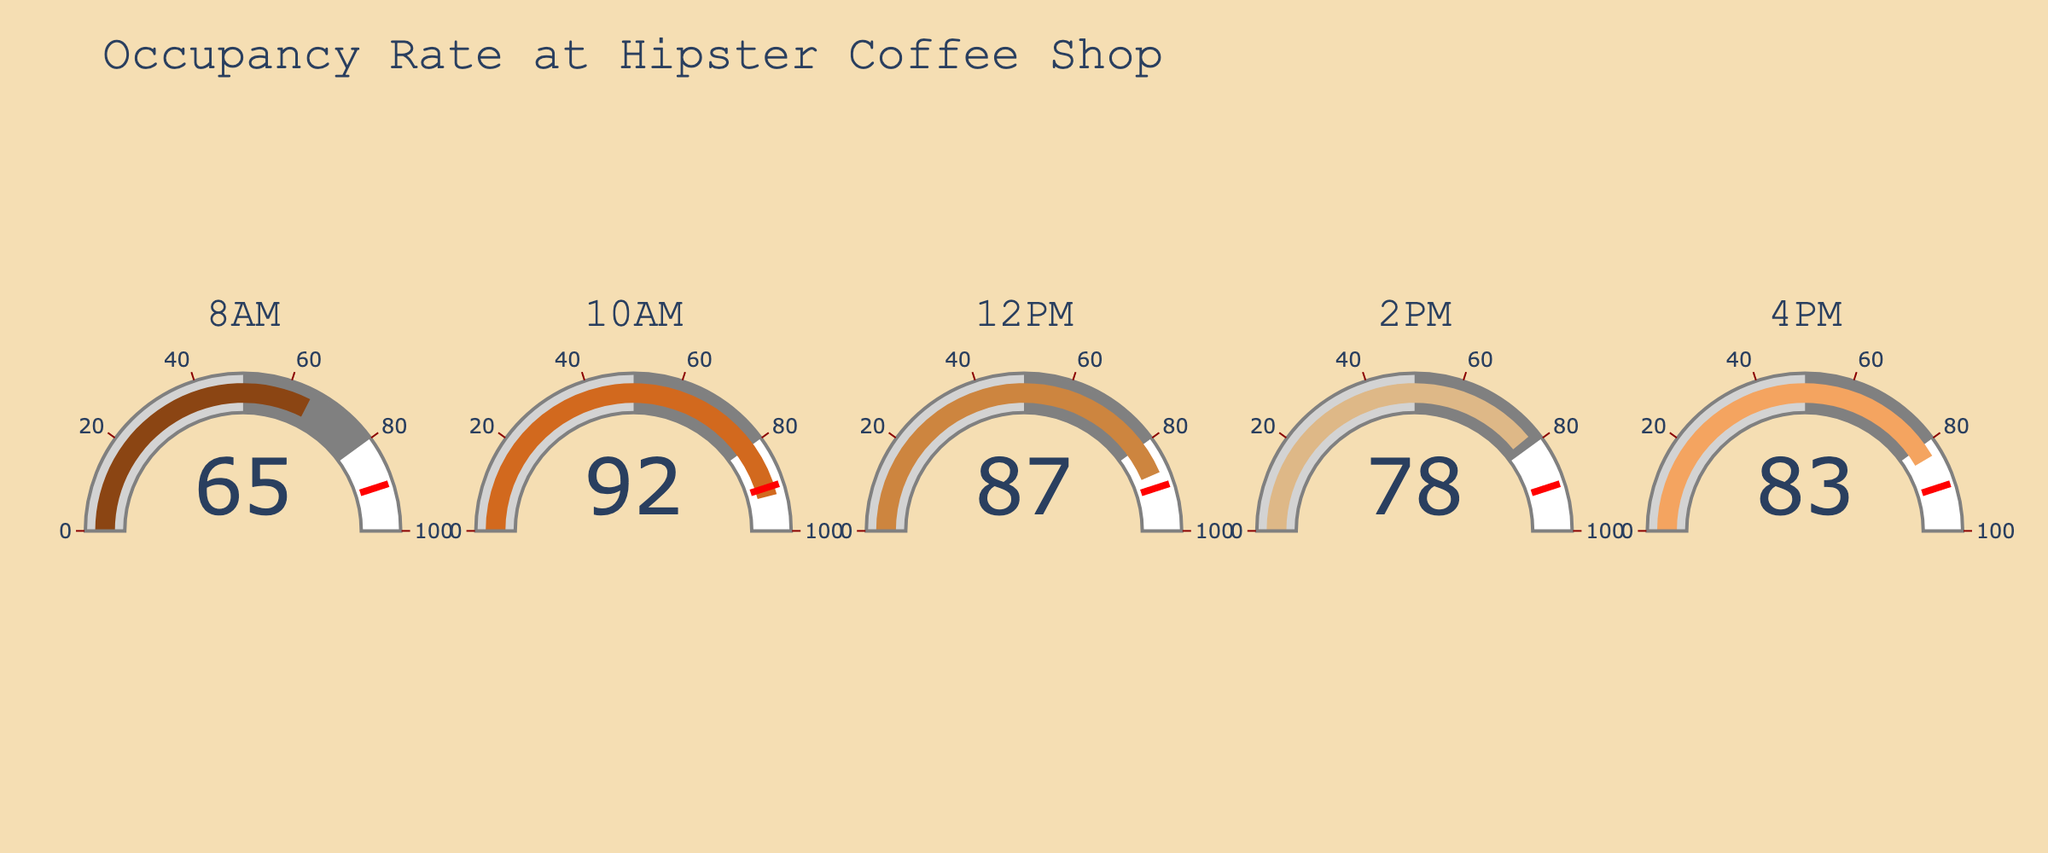What's the peak occupancy rate in the coffee shop during these hours? The highest value among the gauges is 92% at 10AM.
Answer: 92% At what time is the occupancy rate the lowest? The lowest value among the gauges is 65% at 8AM.
Answer: 8AM How much did the occupancy rate increase from 8AM to 10AM? The occupancy rate at 8AM is 65% and at 10AM is 92%. The increase is 92% - 65% = 27%.
Answer: 27% What's the average occupancy rate during these hours? Sum of occupancy rates: 65 + 92 + 87 + 78 + 83 = 405. There are 5 data points. The average is 405 / 5 = 81.
Answer: 81 How does the occupancy rate at 4PM compare to 2PM? The occupancy rate at 4PM is 83% and at 2PM is 78%. So, 83% is higher than 78%.
Answer: 4PM is higher Is there any time slot where the occupancy rate exceeds the threshold of 90%? The threshold is 90%. The occupancy rate exceeds this at 10AM with 92%.
Answer: 10AM What's the range of occupancy rates shown in the gauges? The highest occupancy rate is 92% and the lowest is 65%. The range is 92% - 65% = 27%.
Answer: 27% How many time slots have an occupancy rate above 80%? The occupancy rates above 80% are at 10AM (92%), 12PM (87%), and 4PM (83%). This makes three time slots.
Answer: 3 Which time has a median occupancy rate? The occupancy rates in ascending order: 65%, 78%, 83%, 87%, 92%. The median is the third value, which is at 4PM with 83%.
Answer: 4PM 